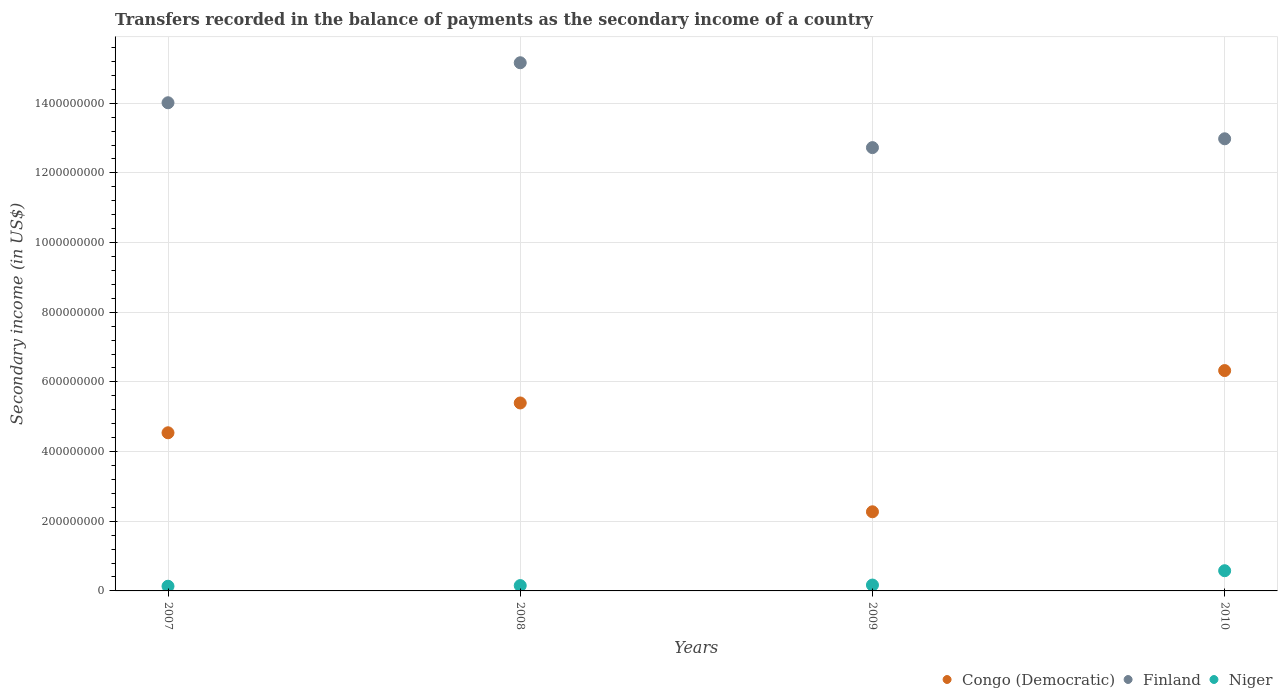How many different coloured dotlines are there?
Ensure brevity in your answer.  3. What is the secondary income of in Congo (Democratic) in 2009?
Keep it short and to the point. 2.27e+08. Across all years, what is the maximum secondary income of in Niger?
Ensure brevity in your answer.  5.80e+07. Across all years, what is the minimum secondary income of in Niger?
Keep it short and to the point. 1.35e+07. In which year was the secondary income of in Finland maximum?
Provide a succinct answer. 2008. In which year was the secondary income of in Finland minimum?
Give a very brief answer. 2009. What is the total secondary income of in Congo (Democratic) in the graph?
Offer a terse response. 1.85e+09. What is the difference between the secondary income of in Congo (Democratic) in 2009 and that in 2010?
Make the answer very short. -4.05e+08. What is the difference between the secondary income of in Finland in 2008 and the secondary income of in Congo (Democratic) in 2009?
Provide a short and direct response. 1.29e+09. What is the average secondary income of in Niger per year?
Offer a very short reply. 2.59e+07. In the year 2010, what is the difference between the secondary income of in Finland and secondary income of in Congo (Democratic)?
Your answer should be compact. 6.65e+08. What is the ratio of the secondary income of in Finland in 2007 to that in 2009?
Keep it short and to the point. 1.1. Is the difference between the secondary income of in Finland in 2008 and 2009 greater than the difference between the secondary income of in Congo (Democratic) in 2008 and 2009?
Keep it short and to the point. No. What is the difference between the highest and the second highest secondary income of in Congo (Democratic)?
Your answer should be very brief. 9.30e+07. What is the difference between the highest and the lowest secondary income of in Niger?
Your answer should be compact. 4.45e+07. Is the secondary income of in Niger strictly greater than the secondary income of in Congo (Democratic) over the years?
Your answer should be compact. No. How many years are there in the graph?
Provide a succinct answer. 4. What is the difference between two consecutive major ticks on the Y-axis?
Keep it short and to the point. 2.00e+08. Are the values on the major ticks of Y-axis written in scientific E-notation?
Ensure brevity in your answer.  No. Does the graph contain grids?
Your answer should be very brief. Yes. Where does the legend appear in the graph?
Provide a succinct answer. Bottom right. How many legend labels are there?
Ensure brevity in your answer.  3. How are the legend labels stacked?
Your answer should be very brief. Horizontal. What is the title of the graph?
Provide a succinct answer. Transfers recorded in the balance of payments as the secondary income of a country. What is the label or title of the Y-axis?
Keep it short and to the point. Secondary income (in US$). What is the Secondary income (in US$) of Congo (Democratic) in 2007?
Make the answer very short. 4.54e+08. What is the Secondary income (in US$) of Finland in 2007?
Your response must be concise. 1.40e+09. What is the Secondary income (in US$) of Niger in 2007?
Ensure brevity in your answer.  1.35e+07. What is the Secondary income (in US$) of Congo (Democratic) in 2008?
Provide a succinct answer. 5.40e+08. What is the Secondary income (in US$) of Finland in 2008?
Your response must be concise. 1.52e+09. What is the Secondary income (in US$) of Niger in 2008?
Your answer should be compact. 1.53e+07. What is the Secondary income (in US$) in Congo (Democratic) in 2009?
Provide a short and direct response. 2.27e+08. What is the Secondary income (in US$) in Finland in 2009?
Your response must be concise. 1.27e+09. What is the Secondary income (in US$) of Niger in 2009?
Your answer should be very brief. 1.69e+07. What is the Secondary income (in US$) in Congo (Democratic) in 2010?
Offer a terse response. 6.33e+08. What is the Secondary income (in US$) of Finland in 2010?
Ensure brevity in your answer.  1.30e+09. What is the Secondary income (in US$) in Niger in 2010?
Give a very brief answer. 5.80e+07. Across all years, what is the maximum Secondary income (in US$) of Congo (Democratic)?
Offer a very short reply. 6.33e+08. Across all years, what is the maximum Secondary income (in US$) of Finland?
Offer a very short reply. 1.52e+09. Across all years, what is the maximum Secondary income (in US$) in Niger?
Your response must be concise. 5.80e+07. Across all years, what is the minimum Secondary income (in US$) in Congo (Democratic)?
Offer a very short reply. 2.27e+08. Across all years, what is the minimum Secondary income (in US$) in Finland?
Make the answer very short. 1.27e+09. Across all years, what is the minimum Secondary income (in US$) of Niger?
Offer a very short reply. 1.35e+07. What is the total Secondary income (in US$) of Congo (Democratic) in the graph?
Give a very brief answer. 1.85e+09. What is the total Secondary income (in US$) of Finland in the graph?
Give a very brief answer. 5.49e+09. What is the total Secondary income (in US$) in Niger in the graph?
Offer a terse response. 1.04e+08. What is the difference between the Secondary income (in US$) in Congo (Democratic) in 2007 and that in 2008?
Offer a very short reply. -8.56e+07. What is the difference between the Secondary income (in US$) in Finland in 2007 and that in 2008?
Offer a very short reply. -1.15e+08. What is the difference between the Secondary income (in US$) of Niger in 2007 and that in 2008?
Give a very brief answer. -1.83e+06. What is the difference between the Secondary income (in US$) of Congo (Democratic) in 2007 and that in 2009?
Your response must be concise. 2.27e+08. What is the difference between the Secondary income (in US$) in Finland in 2007 and that in 2009?
Offer a terse response. 1.29e+08. What is the difference between the Secondary income (in US$) of Niger in 2007 and that in 2009?
Your answer should be compact. -3.37e+06. What is the difference between the Secondary income (in US$) in Congo (Democratic) in 2007 and that in 2010?
Offer a terse response. -1.79e+08. What is the difference between the Secondary income (in US$) of Finland in 2007 and that in 2010?
Keep it short and to the point. 1.03e+08. What is the difference between the Secondary income (in US$) in Niger in 2007 and that in 2010?
Your answer should be very brief. -4.45e+07. What is the difference between the Secondary income (in US$) in Congo (Democratic) in 2008 and that in 2009?
Provide a short and direct response. 3.12e+08. What is the difference between the Secondary income (in US$) of Finland in 2008 and that in 2009?
Your response must be concise. 2.44e+08. What is the difference between the Secondary income (in US$) of Niger in 2008 and that in 2009?
Your response must be concise. -1.55e+06. What is the difference between the Secondary income (in US$) in Congo (Democratic) in 2008 and that in 2010?
Provide a short and direct response. -9.30e+07. What is the difference between the Secondary income (in US$) in Finland in 2008 and that in 2010?
Provide a short and direct response. 2.18e+08. What is the difference between the Secondary income (in US$) of Niger in 2008 and that in 2010?
Give a very brief answer. -4.27e+07. What is the difference between the Secondary income (in US$) of Congo (Democratic) in 2009 and that in 2010?
Ensure brevity in your answer.  -4.05e+08. What is the difference between the Secondary income (in US$) of Finland in 2009 and that in 2010?
Provide a succinct answer. -2.53e+07. What is the difference between the Secondary income (in US$) in Niger in 2009 and that in 2010?
Your answer should be compact. -4.12e+07. What is the difference between the Secondary income (in US$) in Congo (Democratic) in 2007 and the Secondary income (in US$) in Finland in 2008?
Keep it short and to the point. -1.06e+09. What is the difference between the Secondary income (in US$) of Congo (Democratic) in 2007 and the Secondary income (in US$) of Niger in 2008?
Your response must be concise. 4.39e+08. What is the difference between the Secondary income (in US$) in Finland in 2007 and the Secondary income (in US$) in Niger in 2008?
Keep it short and to the point. 1.39e+09. What is the difference between the Secondary income (in US$) in Congo (Democratic) in 2007 and the Secondary income (in US$) in Finland in 2009?
Your response must be concise. -8.19e+08. What is the difference between the Secondary income (in US$) in Congo (Democratic) in 2007 and the Secondary income (in US$) in Niger in 2009?
Provide a succinct answer. 4.37e+08. What is the difference between the Secondary income (in US$) of Finland in 2007 and the Secondary income (in US$) of Niger in 2009?
Provide a short and direct response. 1.38e+09. What is the difference between the Secondary income (in US$) of Congo (Democratic) in 2007 and the Secondary income (in US$) of Finland in 2010?
Your answer should be very brief. -8.44e+08. What is the difference between the Secondary income (in US$) in Congo (Democratic) in 2007 and the Secondary income (in US$) in Niger in 2010?
Offer a terse response. 3.96e+08. What is the difference between the Secondary income (in US$) of Finland in 2007 and the Secondary income (in US$) of Niger in 2010?
Your answer should be compact. 1.34e+09. What is the difference between the Secondary income (in US$) of Congo (Democratic) in 2008 and the Secondary income (in US$) of Finland in 2009?
Offer a very short reply. -7.33e+08. What is the difference between the Secondary income (in US$) in Congo (Democratic) in 2008 and the Secondary income (in US$) in Niger in 2009?
Your answer should be compact. 5.23e+08. What is the difference between the Secondary income (in US$) of Finland in 2008 and the Secondary income (in US$) of Niger in 2009?
Offer a very short reply. 1.50e+09. What is the difference between the Secondary income (in US$) of Congo (Democratic) in 2008 and the Secondary income (in US$) of Finland in 2010?
Your answer should be compact. -7.58e+08. What is the difference between the Secondary income (in US$) in Congo (Democratic) in 2008 and the Secondary income (in US$) in Niger in 2010?
Provide a succinct answer. 4.82e+08. What is the difference between the Secondary income (in US$) of Finland in 2008 and the Secondary income (in US$) of Niger in 2010?
Your answer should be very brief. 1.46e+09. What is the difference between the Secondary income (in US$) in Congo (Democratic) in 2009 and the Secondary income (in US$) in Finland in 2010?
Make the answer very short. -1.07e+09. What is the difference between the Secondary income (in US$) of Congo (Democratic) in 2009 and the Secondary income (in US$) of Niger in 2010?
Your answer should be very brief. 1.69e+08. What is the difference between the Secondary income (in US$) of Finland in 2009 and the Secondary income (in US$) of Niger in 2010?
Keep it short and to the point. 1.21e+09. What is the average Secondary income (in US$) of Congo (Democratic) per year?
Ensure brevity in your answer.  4.63e+08. What is the average Secondary income (in US$) of Finland per year?
Offer a very short reply. 1.37e+09. What is the average Secondary income (in US$) of Niger per year?
Provide a short and direct response. 2.59e+07. In the year 2007, what is the difference between the Secondary income (in US$) of Congo (Democratic) and Secondary income (in US$) of Finland?
Make the answer very short. -9.47e+08. In the year 2007, what is the difference between the Secondary income (in US$) of Congo (Democratic) and Secondary income (in US$) of Niger?
Offer a very short reply. 4.41e+08. In the year 2007, what is the difference between the Secondary income (in US$) in Finland and Secondary income (in US$) in Niger?
Keep it short and to the point. 1.39e+09. In the year 2008, what is the difference between the Secondary income (in US$) in Congo (Democratic) and Secondary income (in US$) in Finland?
Keep it short and to the point. -9.77e+08. In the year 2008, what is the difference between the Secondary income (in US$) of Congo (Democratic) and Secondary income (in US$) of Niger?
Keep it short and to the point. 5.24e+08. In the year 2008, what is the difference between the Secondary income (in US$) of Finland and Secondary income (in US$) of Niger?
Offer a very short reply. 1.50e+09. In the year 2009, what is the difference between the Secondary income (in US$) in Congo (Democratic) and Secondary income (in US$) in Finland?
Your answer should be very brief. -1.05e+09. In the year 2009, what is the difference between the Secondary income (in US$) of Congo (Democratic) and Secondary income (in US$) of Niger?
Give a very brief answer. 2.10e+08. In the year 2009, what is the difference between the Secondary income (in US$) in Finland and Secondary income (in US$) in Niger?
Provide a short and direct response. 1.26e+09. In the year 2010, what is the difference between the Secondary income (in US$) of Congo (Democratic) and Secondary income (in US$) of Finland?
Provide a succinct answer. -6.65e+08. In the year 2010, what is the difference between the Secondary income (in US$) in Congo (Democratic) and Secondary income (in US$) in Niger?
Offer a terse response. 5.75e+08. In the year 2010, what is the difference between the Secondary income (in US$) of Finland and Secondary income (in US$) of Niger?
Provide a succinct answer. 1.24e+09. What is the ratio of the Secondary income (in US$) of Congo (Democratic) in 2007 to that in 2008?
Ensure brevity in your answer.  0.84. What is the ratio of the Secondary income (in US$) of Finland in 2007 to that in 2008?
Provide a short and direct response. 0.92. What is the ratio of the Secondary income (in US$) of Niger in 2007 to that in 2008?
Ensure brevity in your answer.  0.88. What is the ratio of the Secondary income (in US$) in Congo (Democratic) in 2007 to that in 2009?
Offer a very short reply. 2. What is the ratio of the Secondary income (in US$) in Finland in 2007 to that in 2009?
Provide a short and direct response. 1.1. What is the ratio of the Secondary income (in US$) of Niger in 2007 to that in 2009?
Your answer should be compact. 0.8. What is the ratio of the Secondary income (in US$) in Congo (Democratic) in 2007 to that in 2010?
Your answer should be compact. 0.72. What is the ratio of the Secondary income (in US$) in Finland in 2007 to that in 2010?
Provide a short and direct response. 1.08. What is the ratio of the Secondary income (in US$) of Niger in 2007 to that in 2010?
Give a very brief answer. 0.23. What is the ratio of the Secondary income (in US$) of Congo (Democratic) in 2008 to that in 2009?
Your response must be concise. 2.38. What is the ratio of the Secondary income (in US$) of Finland in 2008 to that in 2009?
Keep it short and to the point. 1.19. What is the ratio of the Secondary income (in US$) in Niger in 2008 to that in 2009?
Provide a succinct answer. 0.91. What is the ratio of the Secondary income (in US$) in Congo (Democratic) in 2008 to that in 2010?
Provide a short and direct response. 0.85. What is the ratio of the Secondary income (in US$) of Finland in 2008 to that in 2010?
Provide a succinct answer. 1.17. What is the ratio of the Secondary income (in US$) in Niger in 2008 to that in 2010?
Offer a terse response. 0.26. What is the ratio of the Secondary income (in US$) in Congo (Democratic) in 2009 to that in 2010?
Give a very brief answer. 0.36. What is the ratio of the Secondary income (in US$) in Finland in 2009 to that in 2010?
Your response must be concise. 0.98. What is the ratio of the Secondary income (in US$) in Niger in 2009 to that in 2010?
Provide a short and direct response. 0.29. What is the difference between the highest and the second highest Secondary income (in US$) in Congo (Democratic)?
Ensure brevity in your answer.  9.30e+07. What is the difference between the highest and the second highest Secondary income (in US$) of Finland?
Offer a terse response. 1.15e+08. What is the difference between the highest and the second highest Secondary income (in US$) of Niger?
Give a very brief answer. 4.12e+07. What is the difference between the highest and the lowest Secondary income (in US$) of Congo (Democratic)?
Provide a succinct answer. 4.05e+08. What is the difference between the highest and the lowest Secondary income (in US$) of Finland?
Keep it short and to the point. 2.44e+08. What is the difference between the highest and the lowest Secondary income (in US$) in Niger?
Provide a short and direct response. 4.45e+07. 